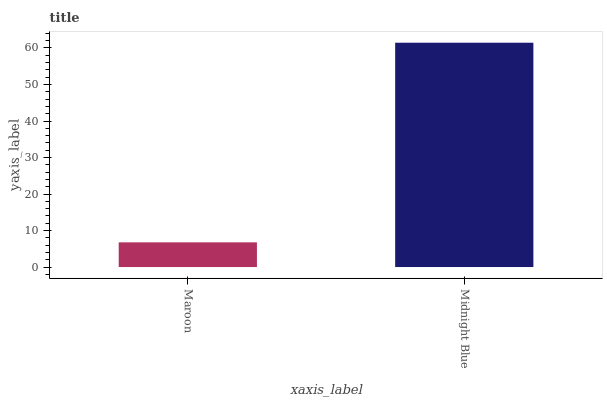Is Maroon the minimum?
Answer yes or no. Yes. Is Midnight Blue the maximum?
Answer yes or no. Yes. Is Midnight Blue the minimum?
Answer yes or no. No. Is Midnight Blue greater than Maroon?
Answer yes or no. Yes. Is Maroon less than Midnight Blue?
Answer yes or no. Yes. Is Maroon greater than Midnight Blue?
Answer yes or no. No. Is Midnight Blue less than Maroon?
Answer yes or no. No. Is Midnight Blue the high median?
Answer yes or no. Yes. Is Maroon the low median?
Answer yes or no. Yes. Is Maroon the high median?
Answer yes or no. No. Is Midnight Blue the low median?
Answer yes or no. No. 